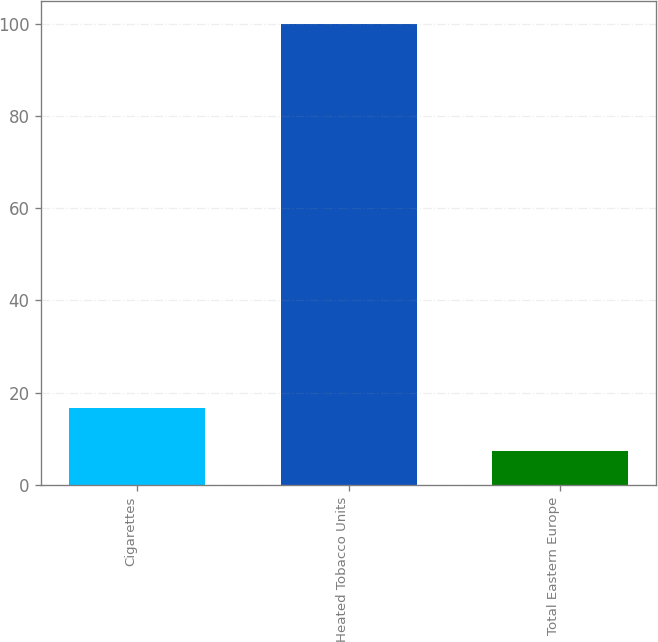Convert chart to OTSL. <chart><loc_0><loc_0><loc_500><loc_500><bar_chart><fcel>Cigarettes<fcel>Heated Tobacco Units<fcel>Total Eastern Europe<nl><fcel>16.57<fcel>100<fcel>7.3<nl></chart> 